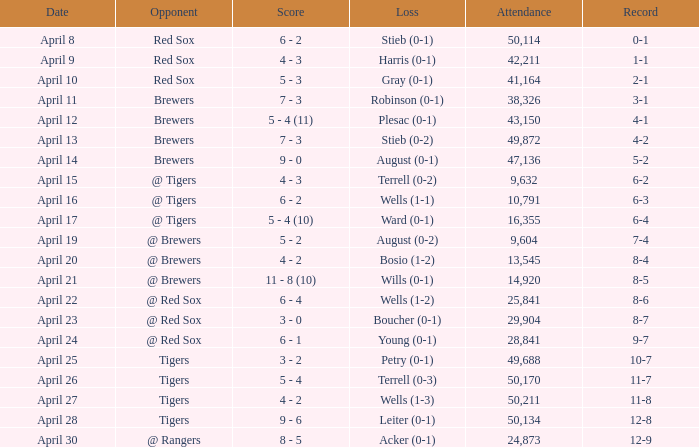Which rival has a decrease in wells (1-3)? Tigers. 